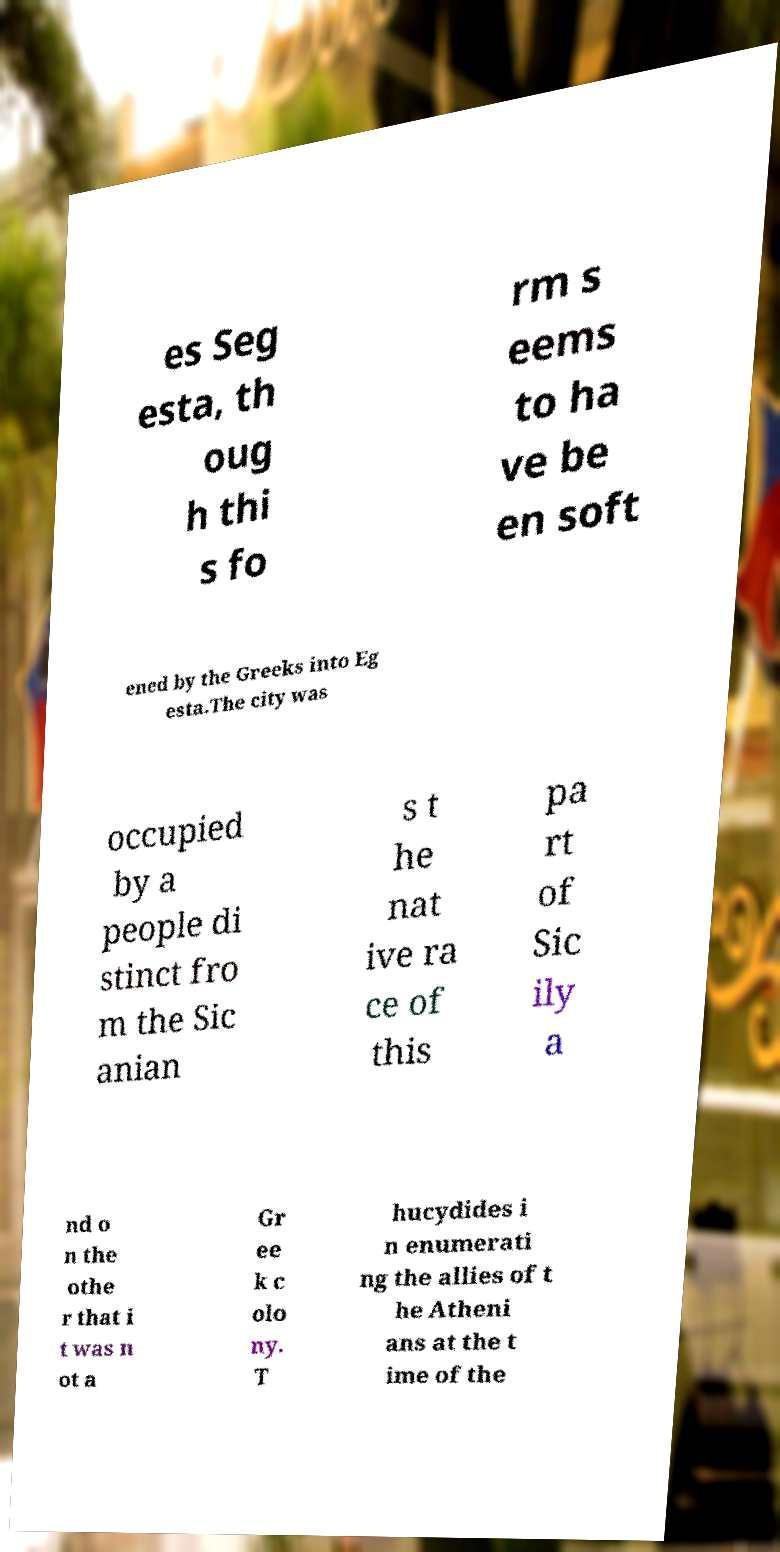Please identify and transcribe the text found in this image. es Seg esta, th oug h thi s fo rm s eems to ha ve be en soft ened by the Greeks into Eg esta.The city was occupied by a people di stinct fro m the Sic anian s t he nat ive ra ce of this pa rt of Sic ily a nd o n the othe r that i t was n ot a Gr ee k c olo ny. T hucydides i n enumerati ng the allies of t he Atheni ans at the t ime of the 